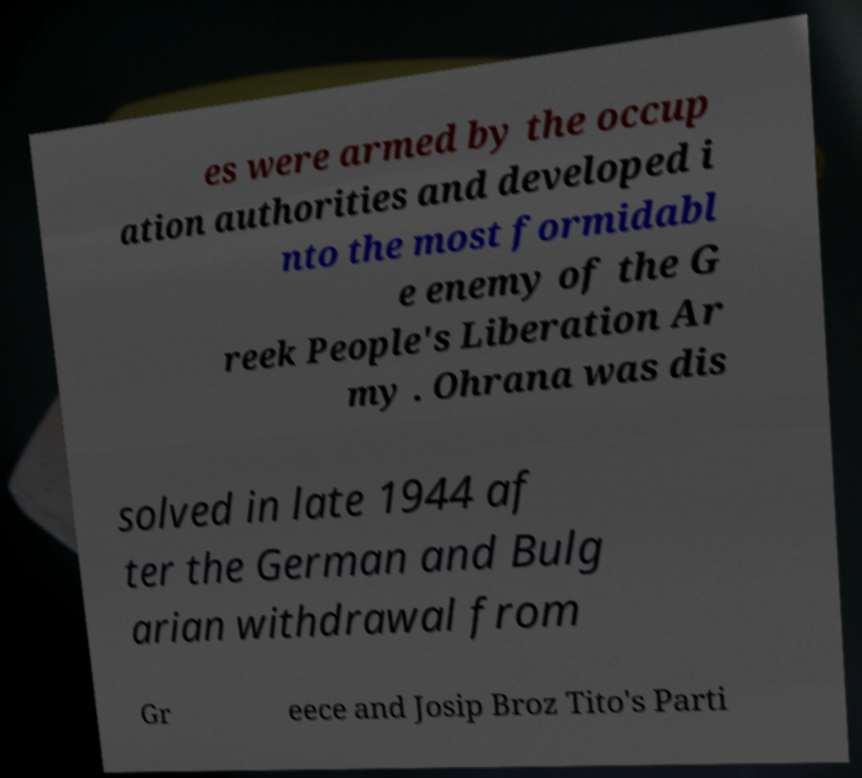Can you accurately transcribe the text from the provided image for me? es were armed by the occup ation authorities and developed i nto the most formidabl e enemy of the G reek People's Liberation Ar my . Ohrana was dis solved in late 1944 af ter the German and Bulg arian withdrawal from Gr eece and Josip Broz Tito's Parti 